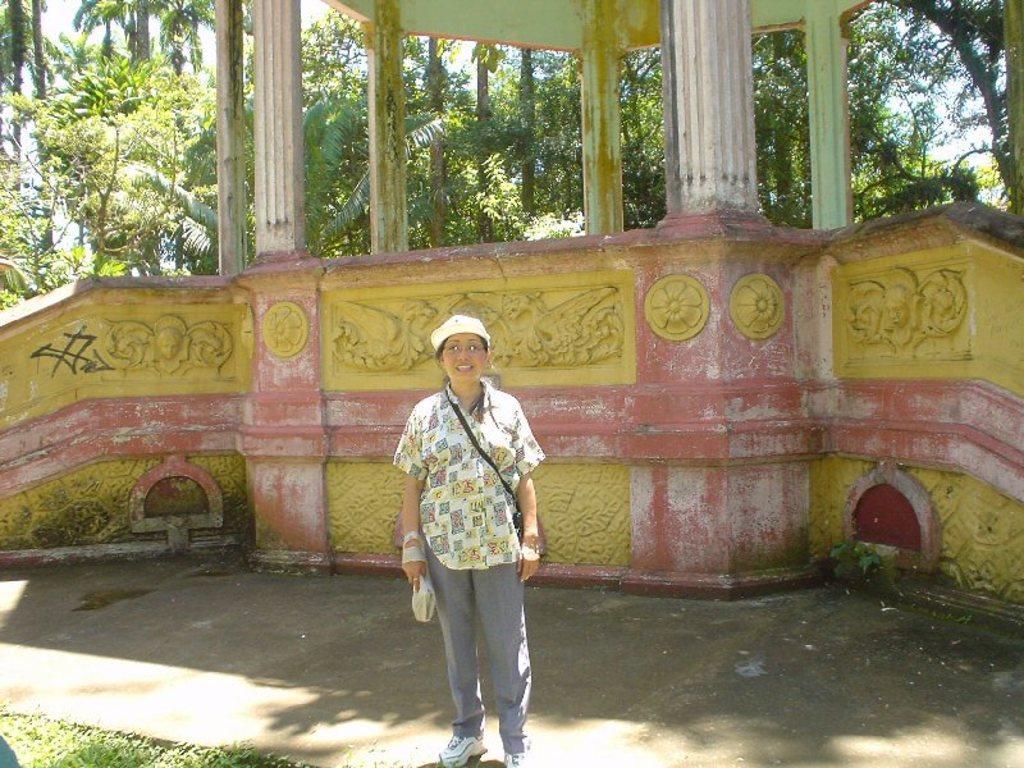Describe this image in one or two sentences. In the middle of the image there is a woman wearing a bag, holding an object in the hand, standing on the ground, smiling and giving pose for the picture. At the back of her there is a wall and also I can see few pillars. In the background there are many trees. In the bottom left there is grass. 